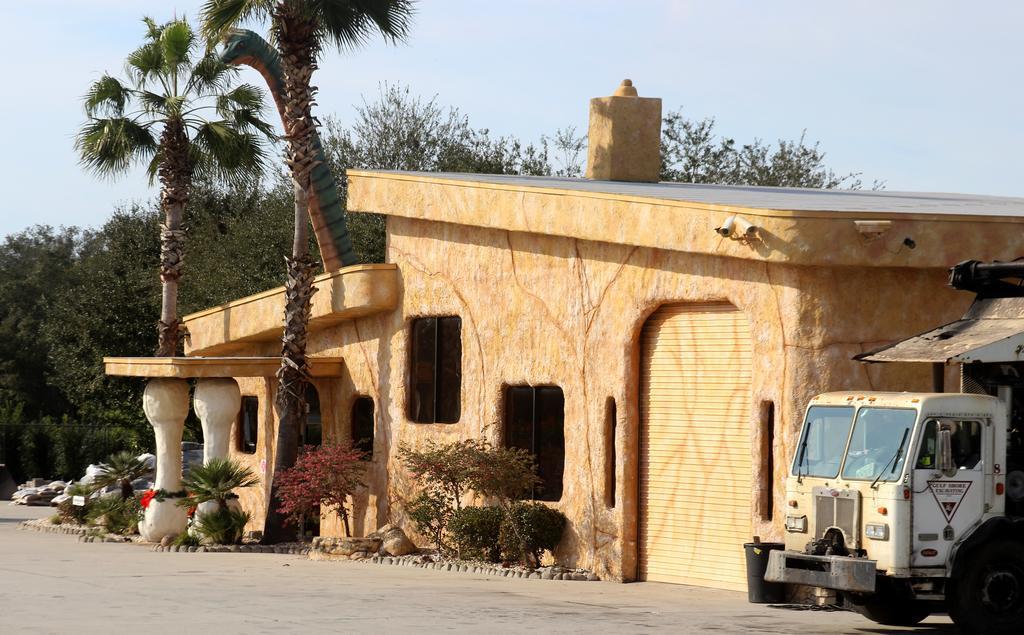Can you describe this image briefly? In the image there is an architecture, beside that there is a vehicle and around the architecture there are plants and trees. 